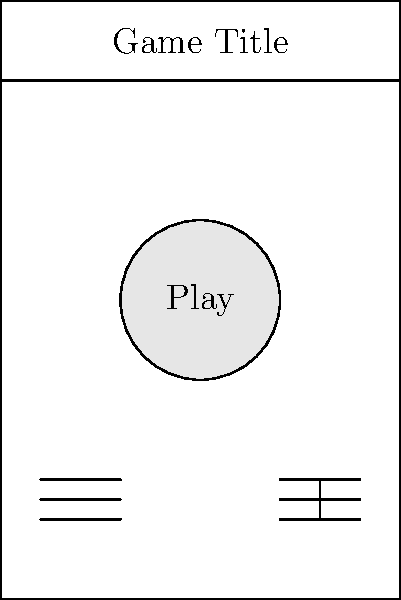Sketch a basic user interface layout for the main menu of your mobile game. Include the following elements: game title, play button, settings button, and leaderboard button. How would you organize these elements to create an intuitive and visually appealing layout? To create an intuitive and visually appealing layout for a mobile game's main menu, follow these steps:

1. Define the screen boundaries:
   Create a rectangle representing the mobile screen dimensions.

2. Place the game title:
   Position the game title at the top of the screen for immediate visibility.

3. Add the play button:
   Place a large, circular play button in the center of the screen, making it the focal point.

4. Include settings and leaderboard buttons:
   Position these buttons at the bottom of the screen, equally spaced for easy access.

5. Consider visual hierarchy:
   Ensure the play button is the largest and most prominent element, followed by the game title, and then the settings and leaderboard buttons.

6. Use appropriate spacing:
   Leave enough space between elements to prevent cluttering and improve readability.

7. Implement consistent styling:
   Use similar shapes and sizes for the settings and leaderboard buttons to maintain visual consistency.

8. Consider touch targets:
   Make buttons large enough for easy tapping on mobile devices.

9. Use color and contrast:
   Although not shown in the sketch, plan to use contrasting colors to make elements stand out and guide the user's attention.

10. Keep it simple:
    Avoid adding unnecessary elements that could distract from the main functionality.

This layout creates an intuitive and visually appealing design by focusing on the core elements of the game's main menu, with a clear visual hierarchy and easy-to-access buttons.
Answer: Centered title at top, large play button in middle, settings and leaderboard buttons at bottom corners. 